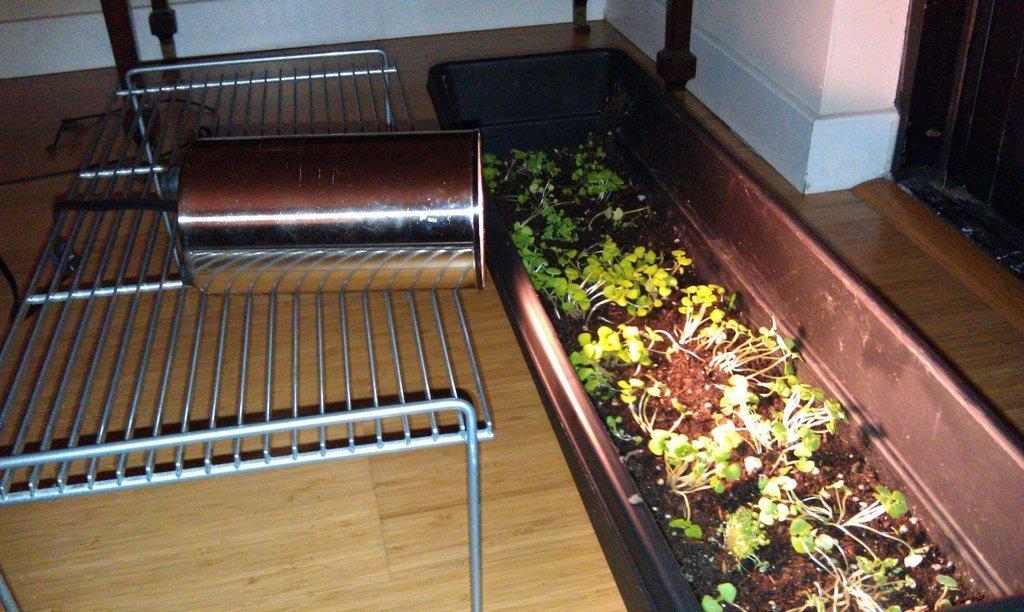How would you summarize this image in a sentence or two? In the center of the image we can see grills, tin, a pot contains plants. At the top of the image wall is there. In the background of the image floor is there. 